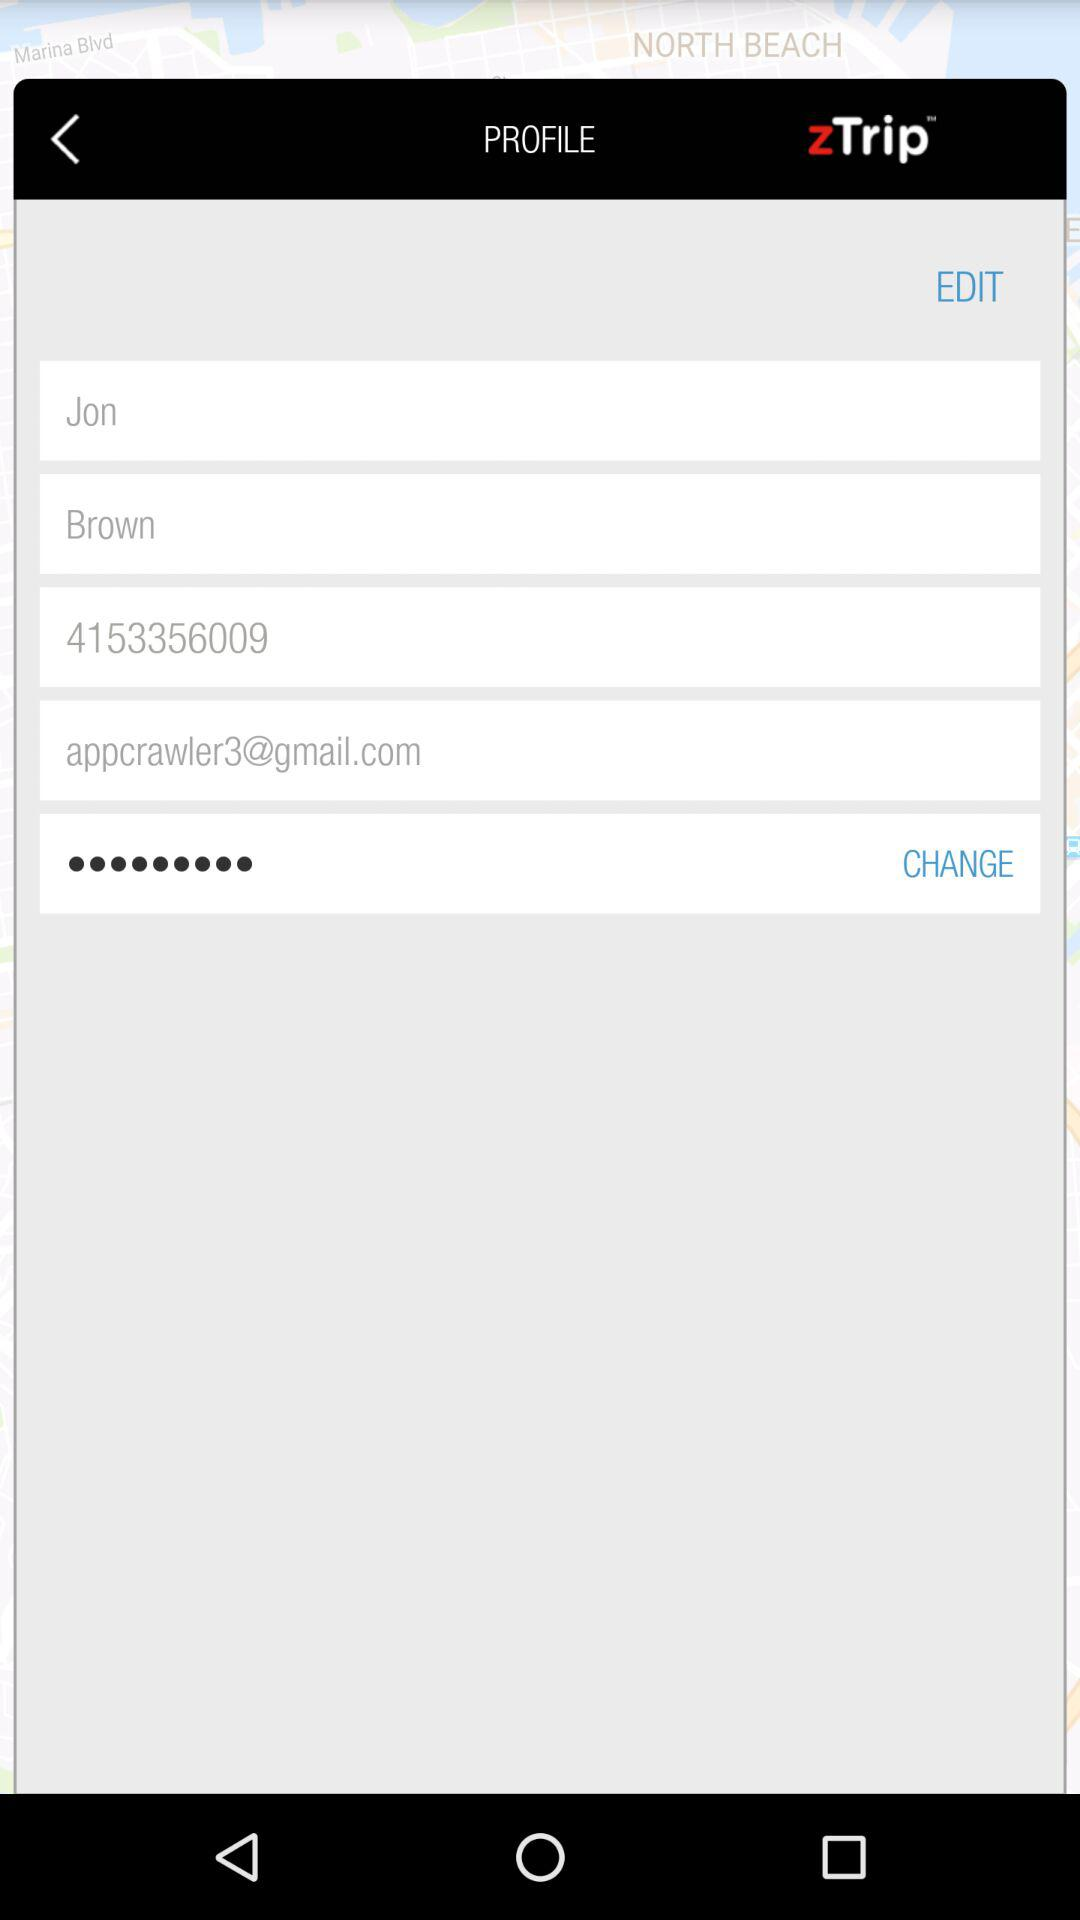What is the first name? The first name is Jon. 